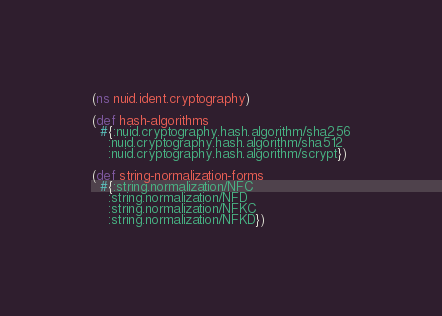Convert code to text. <code><loc_0><loc_0><loc_500><loc_500><_Clojure_>(ns nuid.ident.cryptography)

(def hash-algorithms
  #{:nuid.cryptography.hash.algorithm/sha256
    :nuid.cryptography.hash.algorithm/sha512
    :nuid.cryptography.hash.algorithm/scrypt})

(def string-normalization-forms
  #{:string.normalization/NFC
    :string.normalization/NFD
    :string.normalization/NFKC
    :string.normalization/NFKD})
</code> 